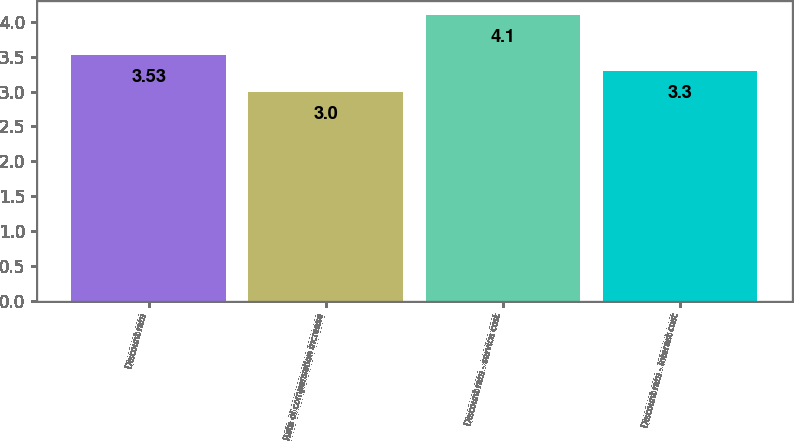<chart> <loc_0><loc_0><loc_500><loc_500><bar_chart><fcel>Discount rate<fcel>Rate of compensation increase<fcel>Discount rate - service cost<fcel>Discount rate - interest cost<nl><fcel>3.53<fcel>3<fcel>4.1<fcel>3.3<nl></chart> 